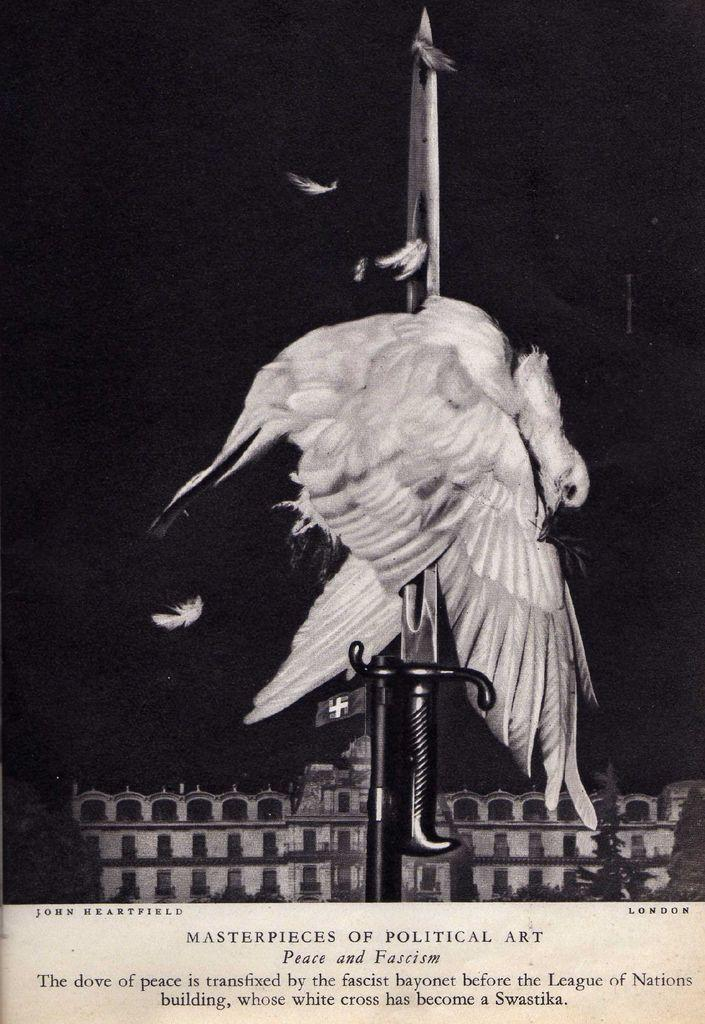<image>
Render a clear and concise summary of the photo. A poster advertising for Masterpieces in Political Art. 